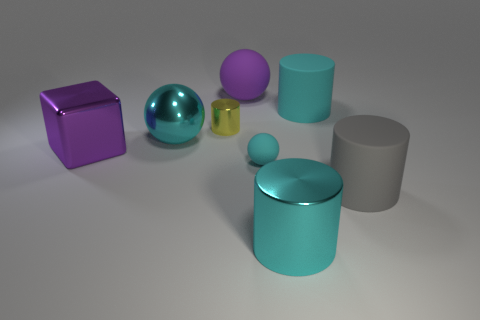There is a shiny thing in front of the tiny ball; are there any cylinders on the right side of it?
Make the answer very short. Yes. What shape is the purple object that is made of the same material as the gray thing?
Make the answer very short. Sphere. Is there any other thing of the same color as the big shiny ball?
Offer a terse response. Yes. What material is the other gray thing that is the same shape as the small metal object?
Make the answer very short. Rubber. How many other things are the same size as the yellow shiny thing?
Give a very brief answer. 1. There is a ball that is the same color as the small rubber object; what is its size?
Offer a terse response. Large. Is the shape of the cyan shiny thing that is in front of the purple shiny object the same as  the tiny cyan rubber thing?
Ensure brevity in your answer.  No. How many other objects are there of the same shape as the big cyan matte object?
Offer a terse response. 3. What shape is the purple thing on the right side of the big cube?
Make the answer very short. Sphere. Are there any tiny cyan balls made of the same material as the big gray cylinder?
Offer a very short reply. Yes. 